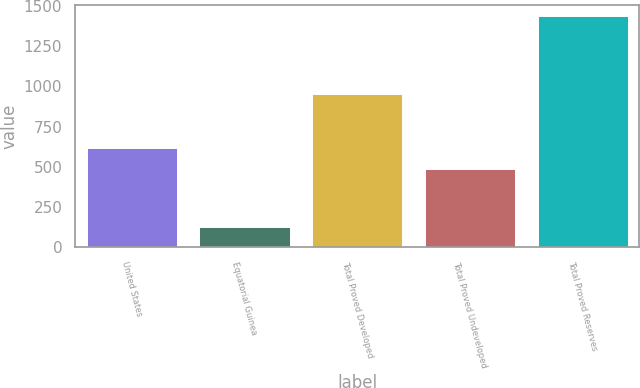Convert chart. <chart><loc_0><loc_0><loc_500><loc_500><bar_chart><fcel>United States<fcel>Equatorial Guinea<fcel>Total Proved Developed<fcel>Total Proved Undeveloped<fcel>Total Proved Reserves<nl><fcel>617<fcel>127<fcel>951<fcel>486<fcel>1437<nl></chart> 